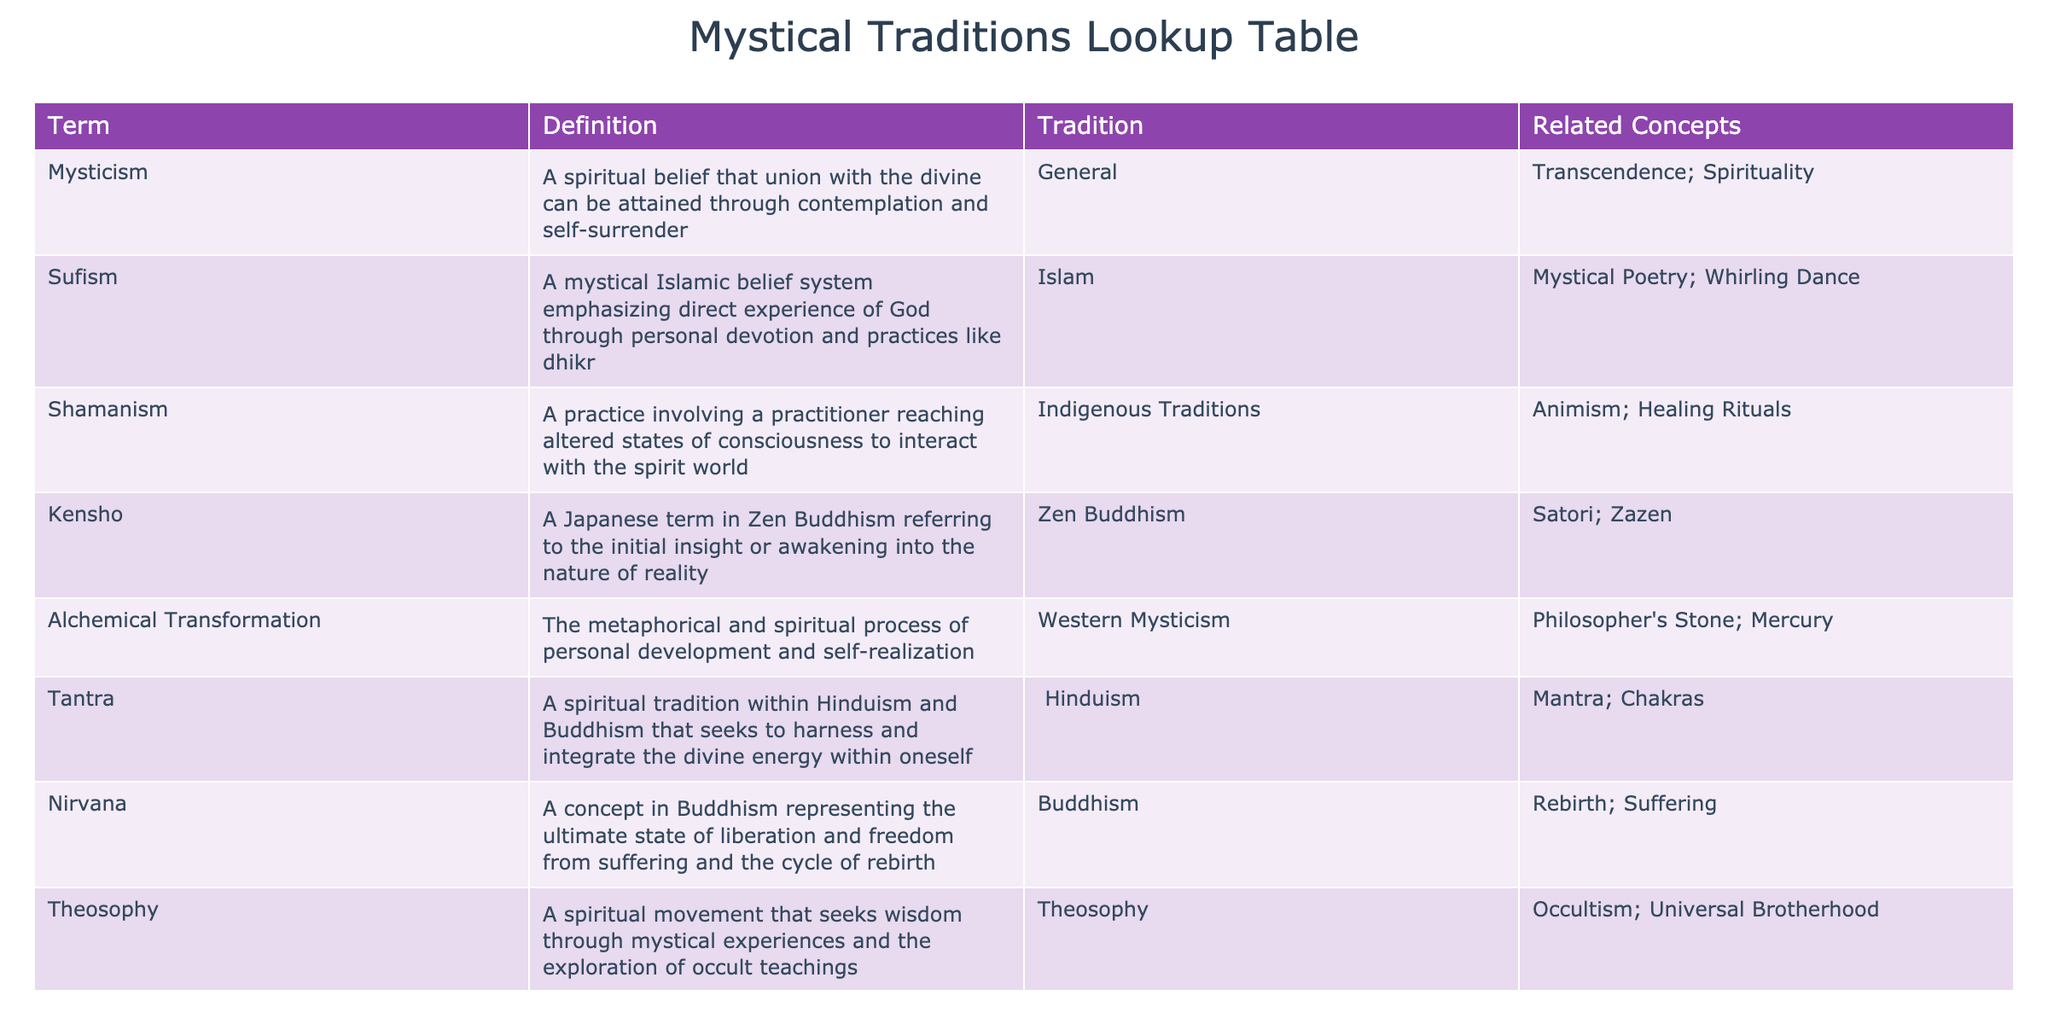What is the definition of Sufism? According to the table, Sufism is defined as a mystical Islamic belief system emphasizing direct experience of God through personal devotion and practices like dhikr.
Answer: A mystical Islamic belief system emphasizing direct experience of God through personal devotion and practices like dhikr Which tradition does the term "Nirvana" belong to? The table indicates that Nirvana is a concept in Buddhism, so it belongs to the Buddhism tradition.
Answer: Buddhism Is "Alchemical Transformation" related to "Philosopher's Stone"? Yes, the table lists "Philosopher's Stone" as one of the related concepts for Alchemical Transformation, indicating a connection between the two.
Answer: Yes Which terms in the table are associated with Hinduism? The table shows that the term "Tantra" is associated with Hinduism. There are no other terms related to Hinduism listed in the data.
Answer: Tantra What is the relationship between Shamanism and Animism? The table states that Shamanism is related to Animism, suggesting that practitioners of Shamanism often engage with animistic beliefs or practices concerning the spirit world.
Answer: Related What are the two concepts associated with Zen Buddhism? By examining the table, Zen Buddhism is associated with the concepts of Satori and Zazen. This can be gathered by looking at the related concepts column next to the Zen Buddhism entry.
Answer: Satori; Zazen How many mystical traditions are mentioned in the table? The table lists a total of six mystical traditions: General, Islam, Indigenous Traditions, Zen Buddhism, Western Mysticism, and Hinduism. This is determined by counting the unique traditions listed in the third column.
Answer: Six Are all the mystical traditions focused on personal experiences? No, while many listed terms emphasize personal experiences, not all describe an individual experience of the divine; for instance, Theosophy focuses on mystical experiences through exploration of teachings rather than just personal devotion.
Answer: No What is the average number of related concepts for each tradition listed? Counting the related concepts for each tradition: General (2), Islam (2), Indigenous Traditions (2), Zen Buddhism (2), Western Mysticism (2), Hinduism (2), and Buddhism (2) gives a total of 12 related concepts across 6 traditions. Thus, the average is 12/6 = 2.
Answer: 2 